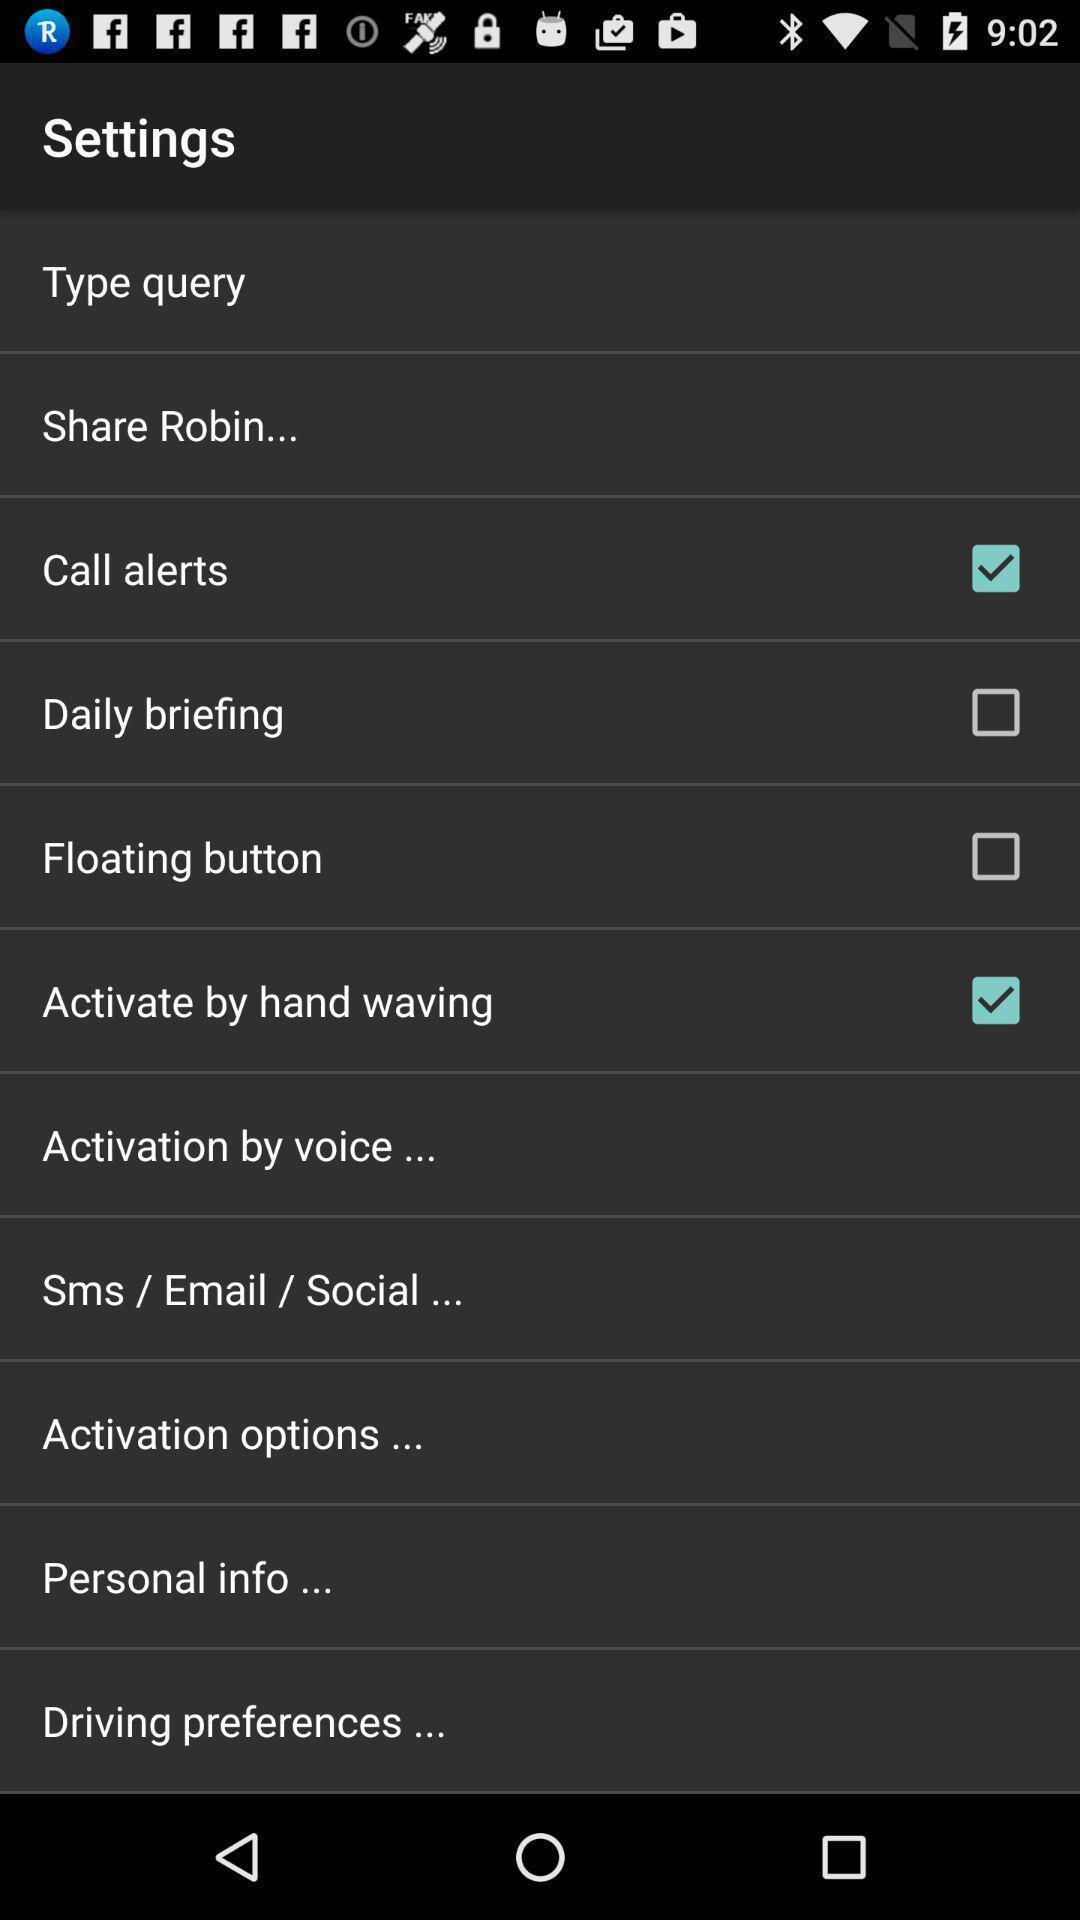Summarize the information in this screenshot. Settings page in an news and radio app. 